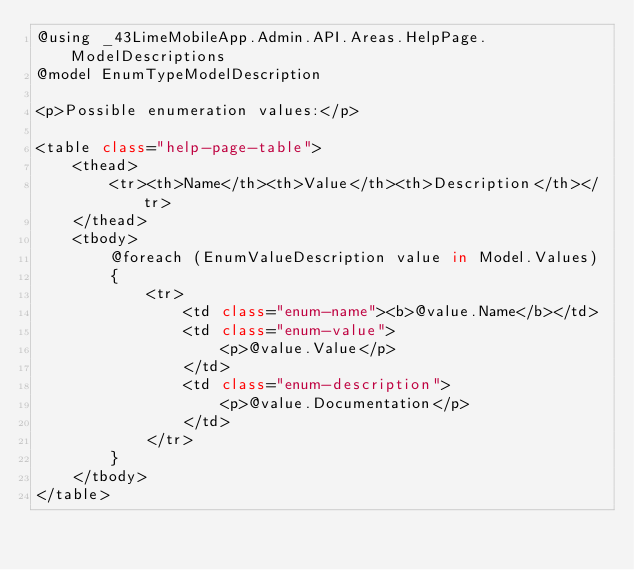<code> <loc_0><loc_0><loc_500><loc_500><_C#_>@using _43LimeMobileApp.Admin.API.Areas.HelpPage.ModelDescriptions
@model EnumTypeModelDescription

<p>Possible enumeration values:</p>

<table class="help-page-table">
    <thead>
        <tr><th>Name</th><th>Value</th><th>Description</th></tr>
    </thead>
    <tbody>
        @foreach (EnumValueDescription value in Model.Values)
        {
            <tr>
                <td class="enum-name"><b>@value.Name</b></td>
                <td class="enum-value">
                    <p>@value.Value</p>
                </td>
                <td class="enum-description">
                    <p>@value.Documentation</p>
                </td>
            </tr>
        }
    </tbody>
</table></code> 